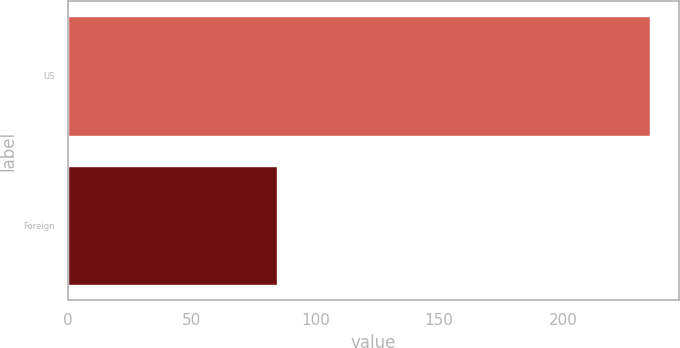Convert chart to OTSL. <chart><loc_0><loc_0><loc_500><loc_500><bar_chart><fcel>US<fcel>Foreign<nl><fcel>235.3<fcel>84.4<nl></chart> 